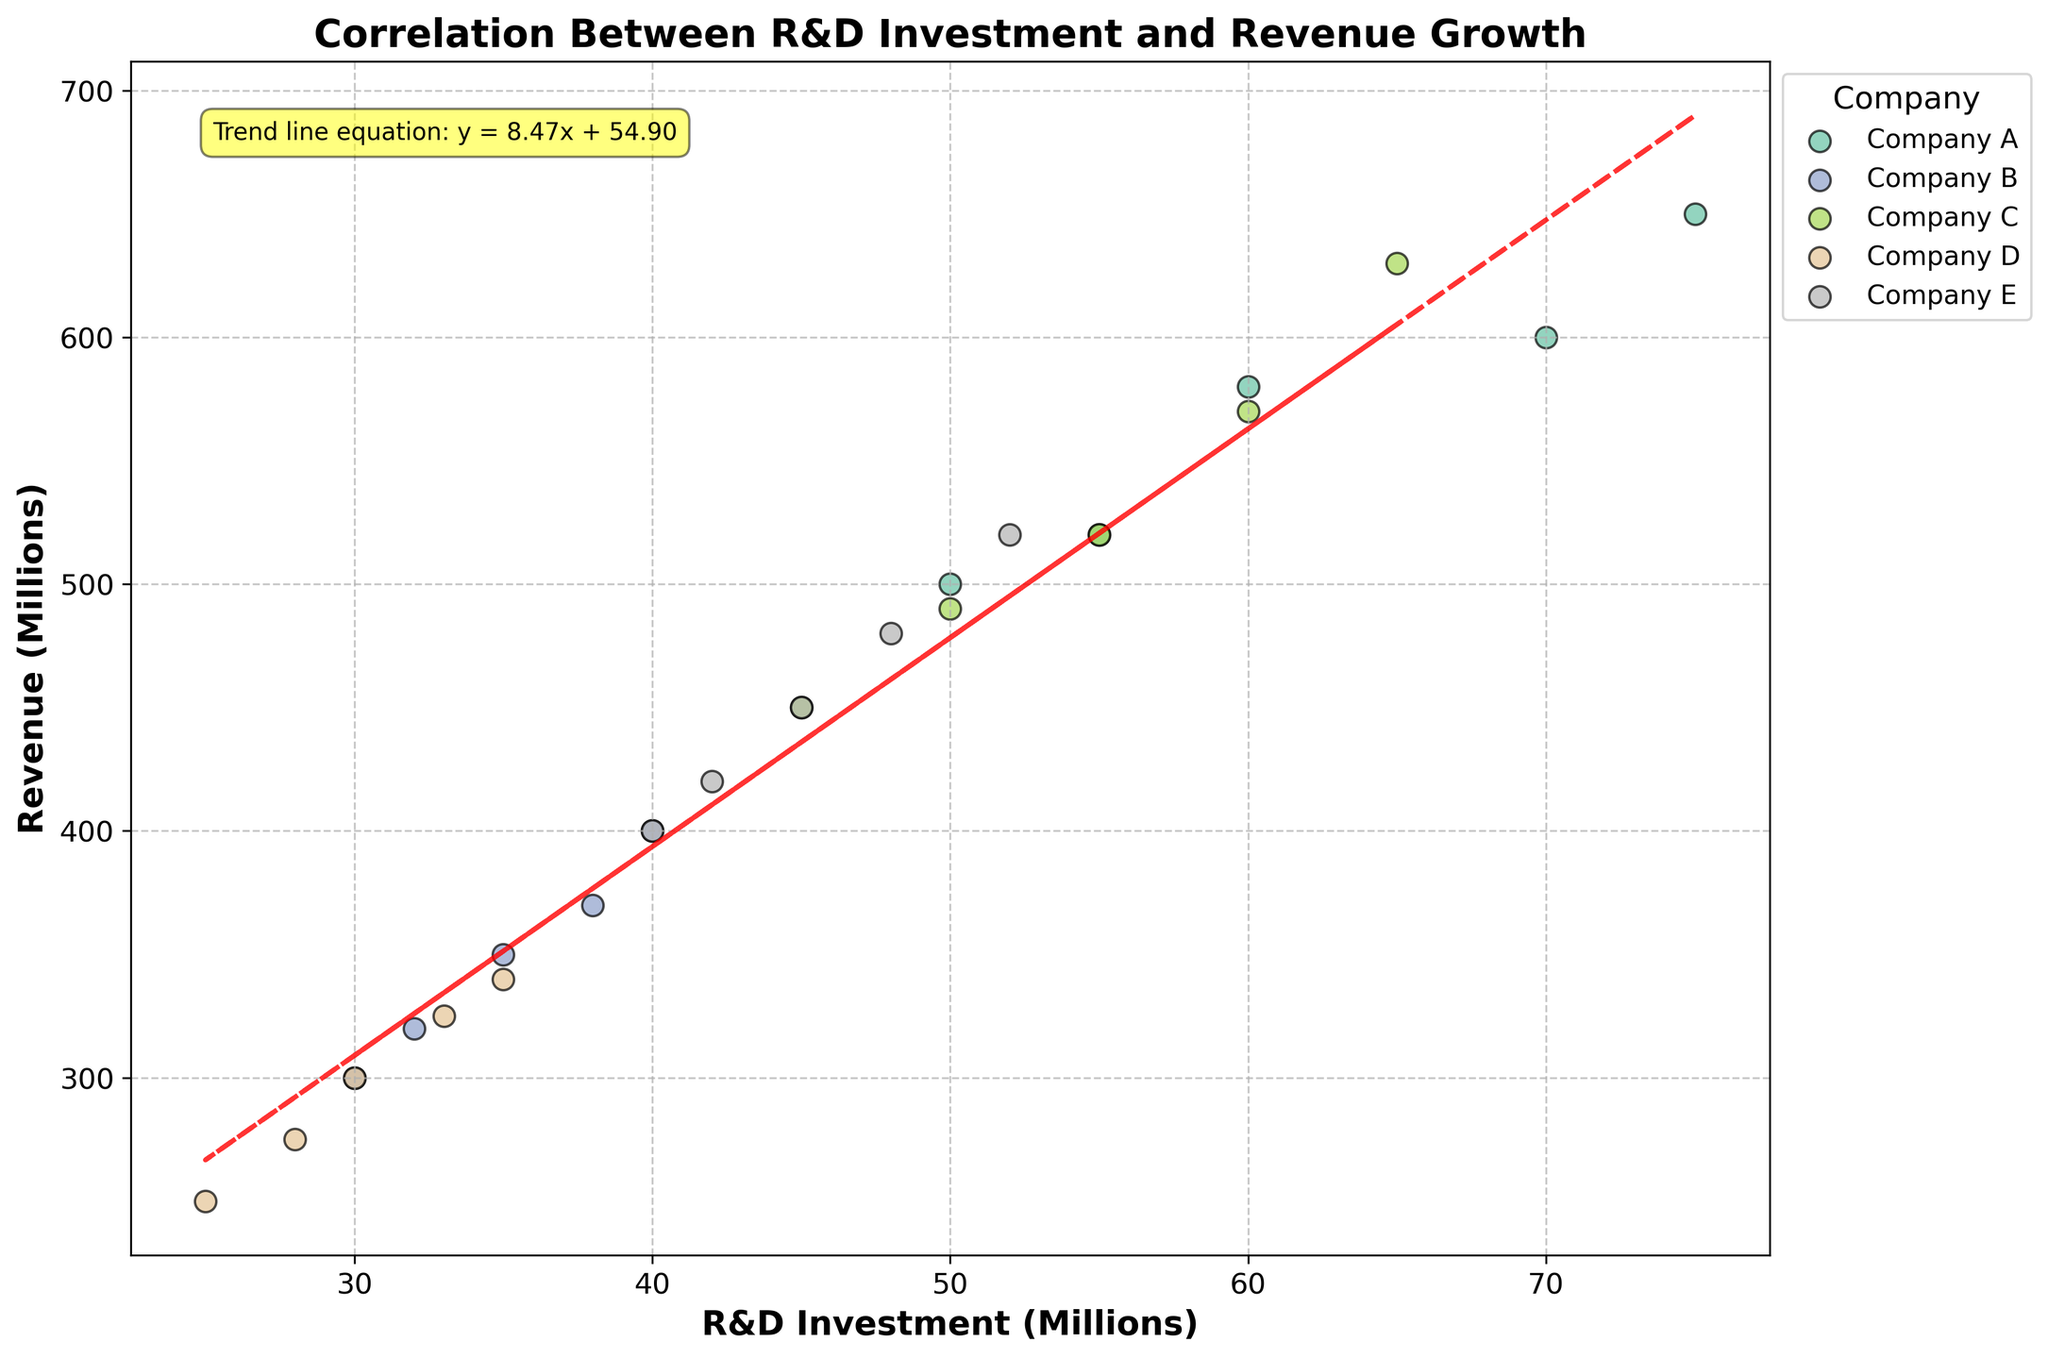What is the title of the figure? The title of the figure is displayed at the top in bold font. It reads "Correlation Between R&D Investment and Revenue Growth".
Answer: Correlation Between R&D Investment and Revenue Growth What is shown on the x-axis of the figure? The x-axis of the figure represents R&D Investment in Millions, as labeled.
Answer: R&D Investment (Millions) How many companies are represented in the scatter plot? The legend shows that five companies are represented: Company A, Company B, Company C, Company D, and Company E.
Answer: 5 What is the equation of the trend line? The trend line equation is annotated on the plot with a box. It reads 'y = 1.9x + 130.0'.
Answer: y = 1.9x + 130.0 Which company has the highest R&D investment in 2022? By comparing individual data points, Company A in 2022 has the highest R&D investment at 75 million USD.
Answer: Company A How does Company B's revenue growth from 2018 to 2022 compare to Company D's? Company B's revenue grows from 300 to 400 million USD, a total increment of 100 million. Company D's revenue grows from 250 to 340 million USD, a total increment of 90 million. Company B's revenue growth is higher.
Answer: Company B's revenue growth is higher What is the trend between R&D investment and revenue? The trend line equation 'y = 1.9x + 130.0' indicates that for every additional million invested in R&D, the revenue increases by 1.9 million.
Answer: Positive correlation Which company shows the largest increase in revenue over the years represented? Across the years, Company A's revenue increased from 500 to 650 million USD, which is a total increment of 150 million, the largest among the companies listed.
Answer: Company A Based on the trend line, what revenue would you expect if a company invested 50 million in R&D? Using the trend line equation y = 1.9x + 130, if R&D investment is 50 million, then y = 1.9*50 + 130 = 95 + 130 = 225. Expected revenue is 225 million USD.
Answer: 225 million USD 